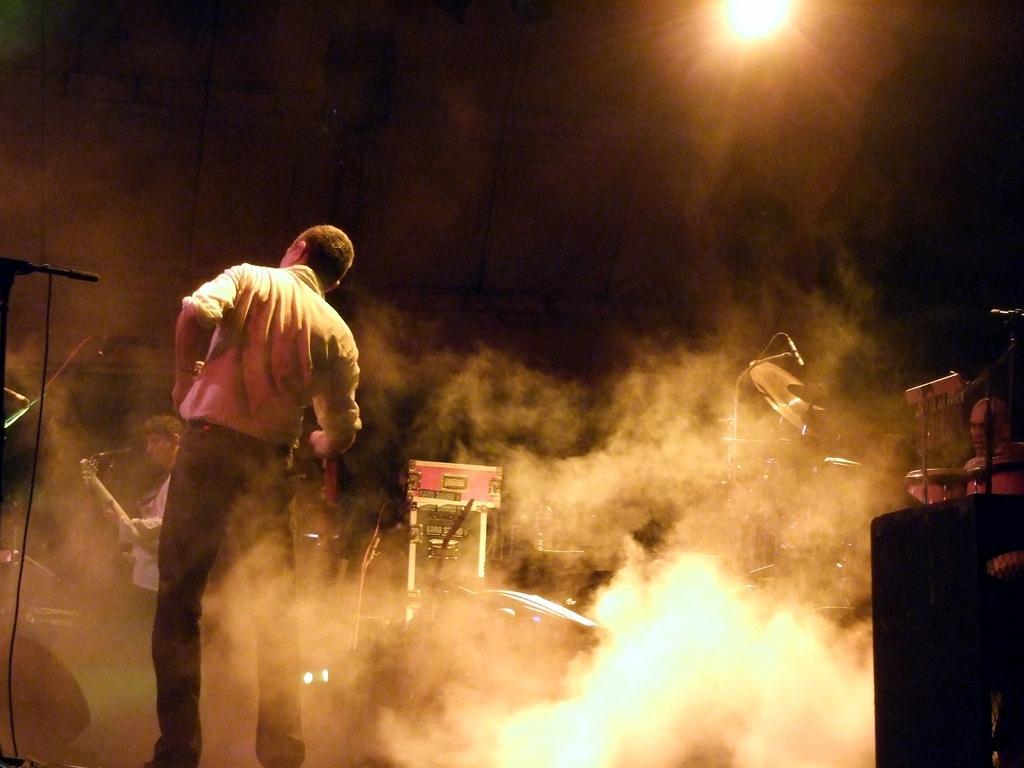In one or two sentences, can you explain what this image depicts? In this image I can see there are two persons standing on the floor on the left side , at the top I can see the light , in the middle I can see the fog and musical instruments. 